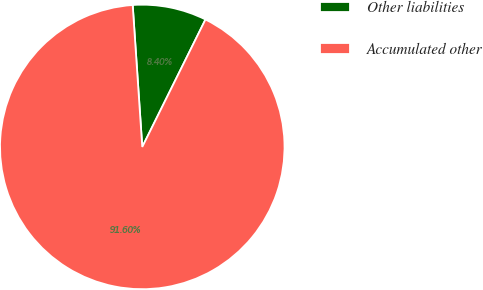Convert chart to OTSL. <chart><loc_0><loc_0><loc_500><loc_500><pie_chart><fcel>Other liabilities<fcel>Accumulated other<nl><fcel>8.4%<fcel>91.6%<nl></chart> 